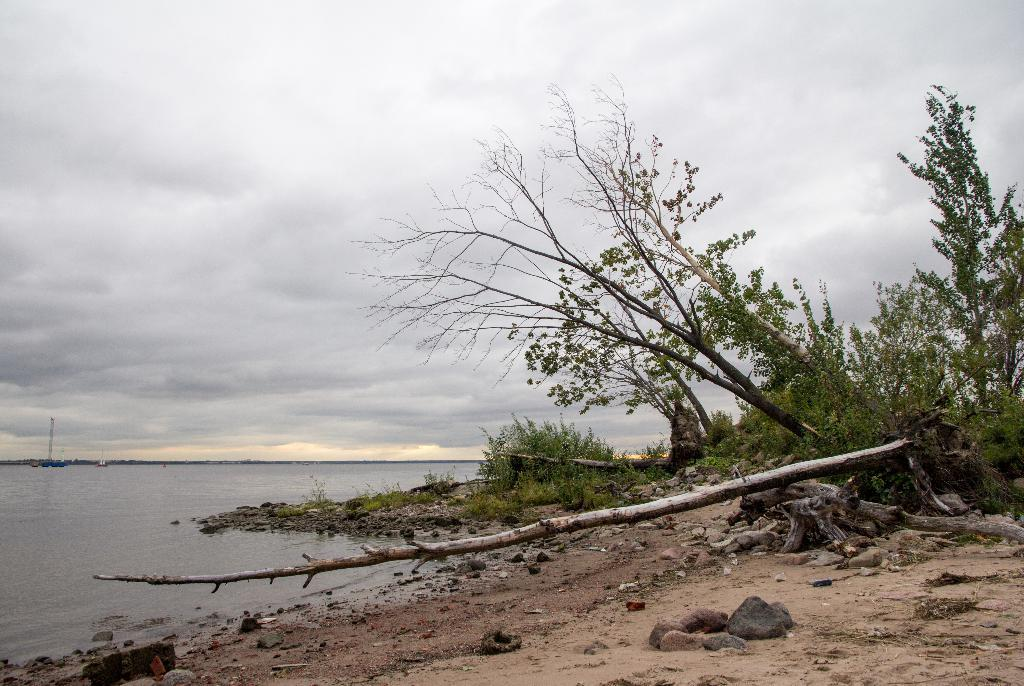What type of body of water is in the image? There is a lake in the image. What can be seen on the right side of the image? Trees, rocks, sand, and plants are present on the right side of the image. What is visible at the top of the image? The sky is visible at the top of the image. What memory does the boy have of the lake in the image? There is no boy present in the image, so it is not possible to determine any memories related to the lake. 